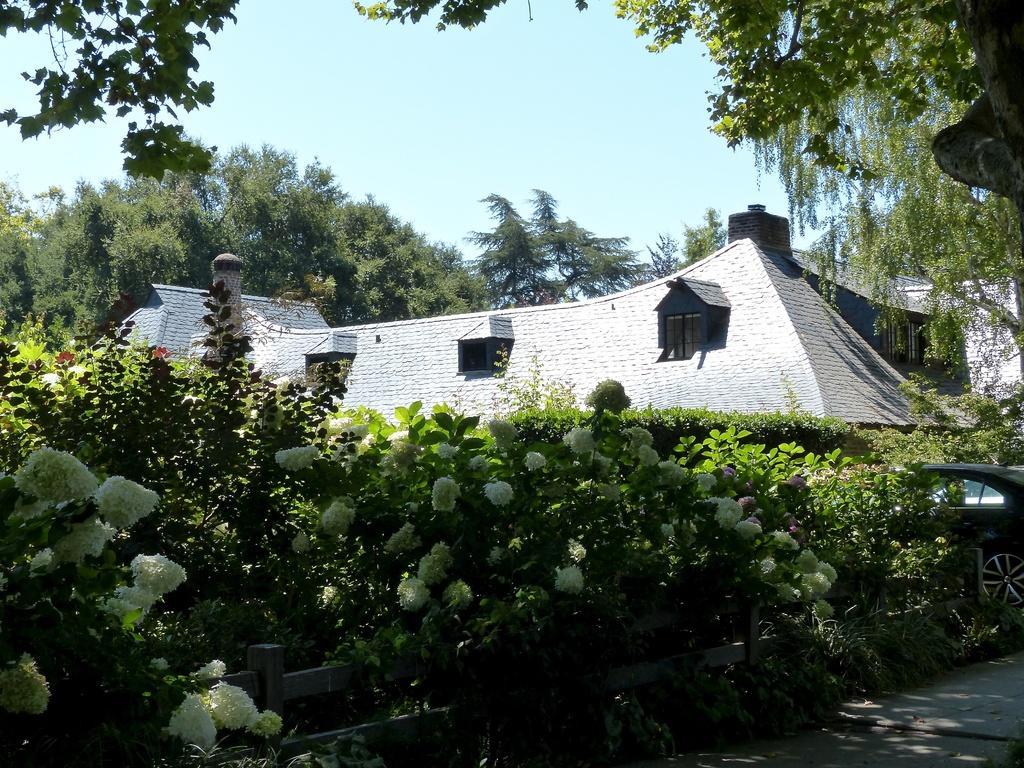Describe this image in one or two sentences. In this picture we can see some plants and flowers in the front, on the right side there is a car, we can see a house in the middle, in the background there are trees, we can see the sky at the top of the picture. 